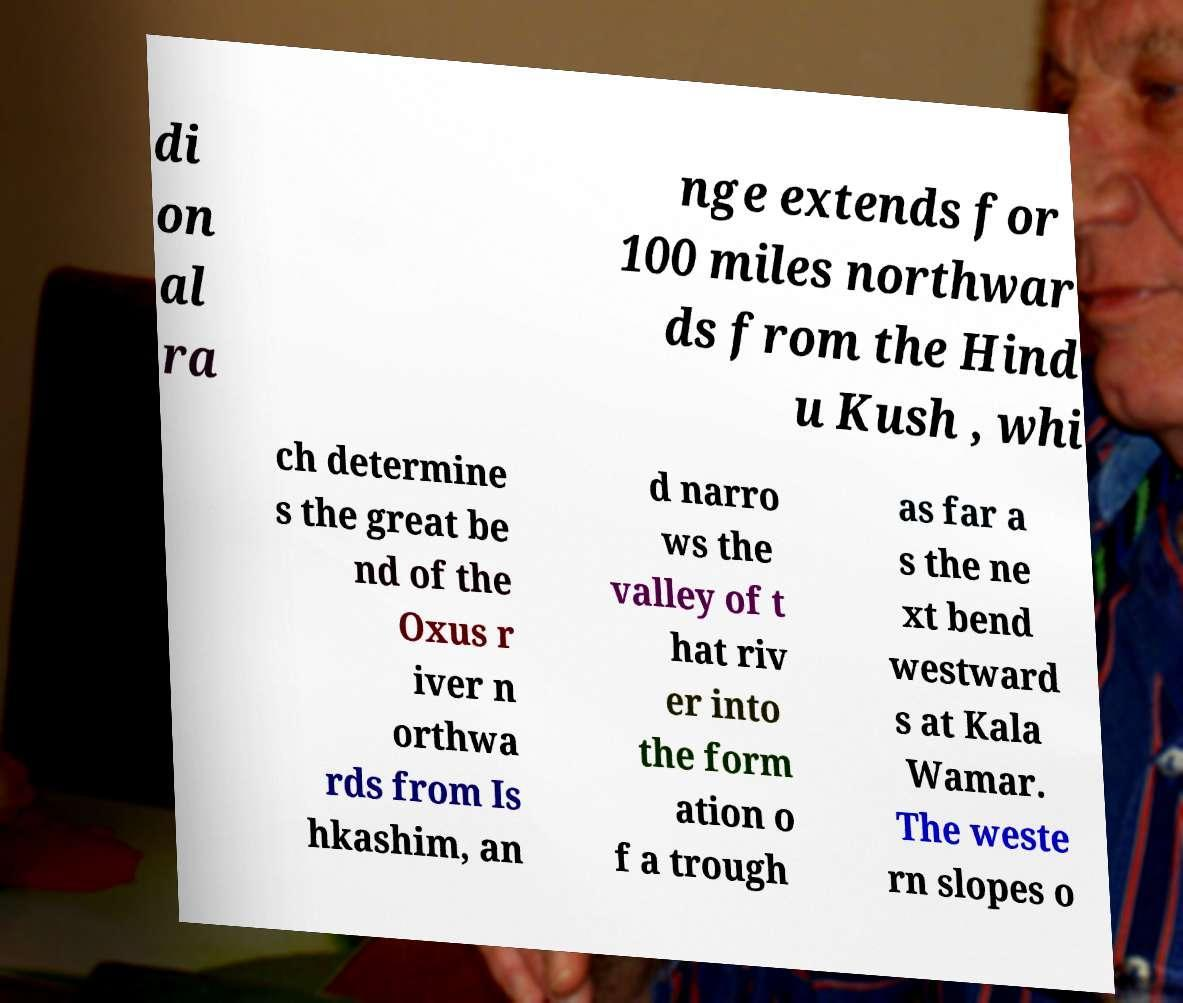Please identify and transcribe the text found in this image. di on al ra nge extends for 100 miles northwar ds from the Hind u Kush , whi ch determine s the great be nd of the Oxus r iver n orthwa rds from Is hkashim, an d narro ws the valley of t hat riv er into the form ation o f a trough as far a s the ne xt bend westward s at Kala Wamar. The weste rn slopes o 